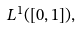Convert formula to latex. <formula><loc_0><loc_0><loc_500><loc_500>L ^ { 1 } ( [ 0 , 1 ] ) ,</formula> 